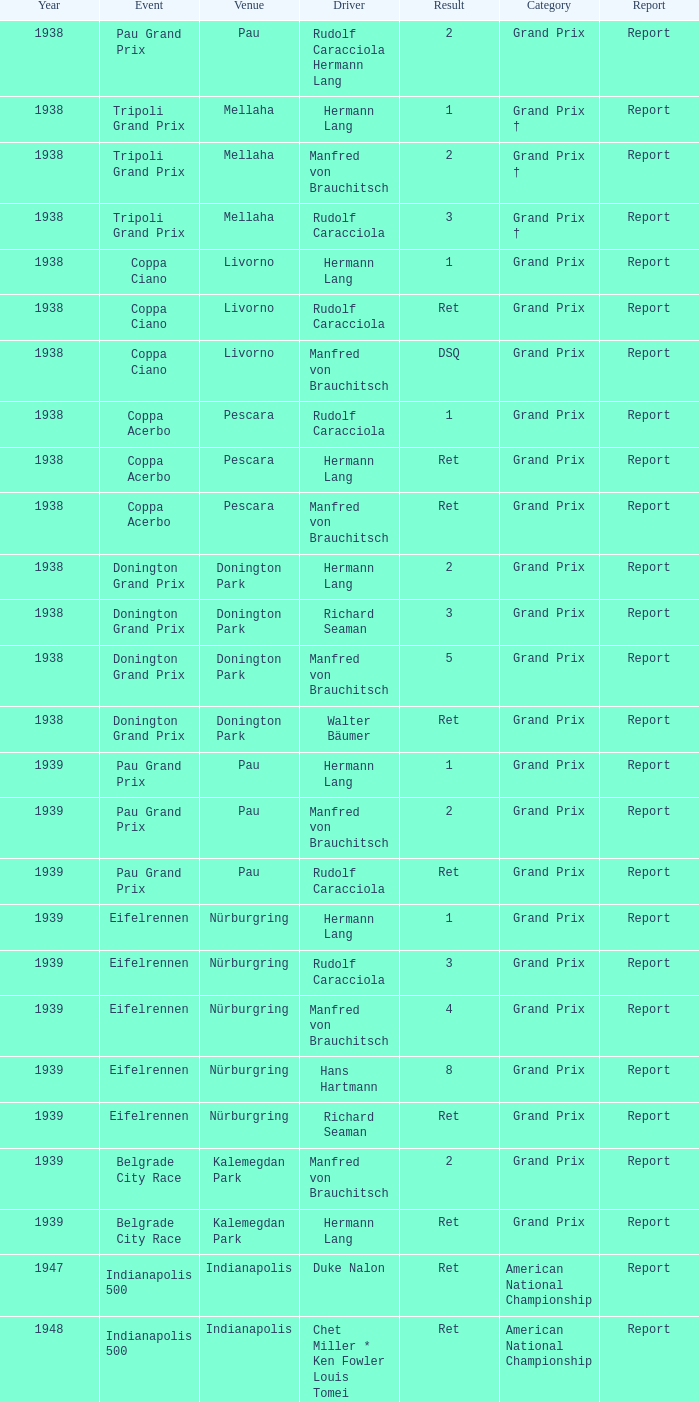When did Hans Hartmann drive? 1.0. 